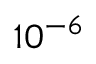Convert formula to latex. <formula><loc_0><loc_0><loc_500><loc_500>1 0 ^ { - 6 }</formula> 